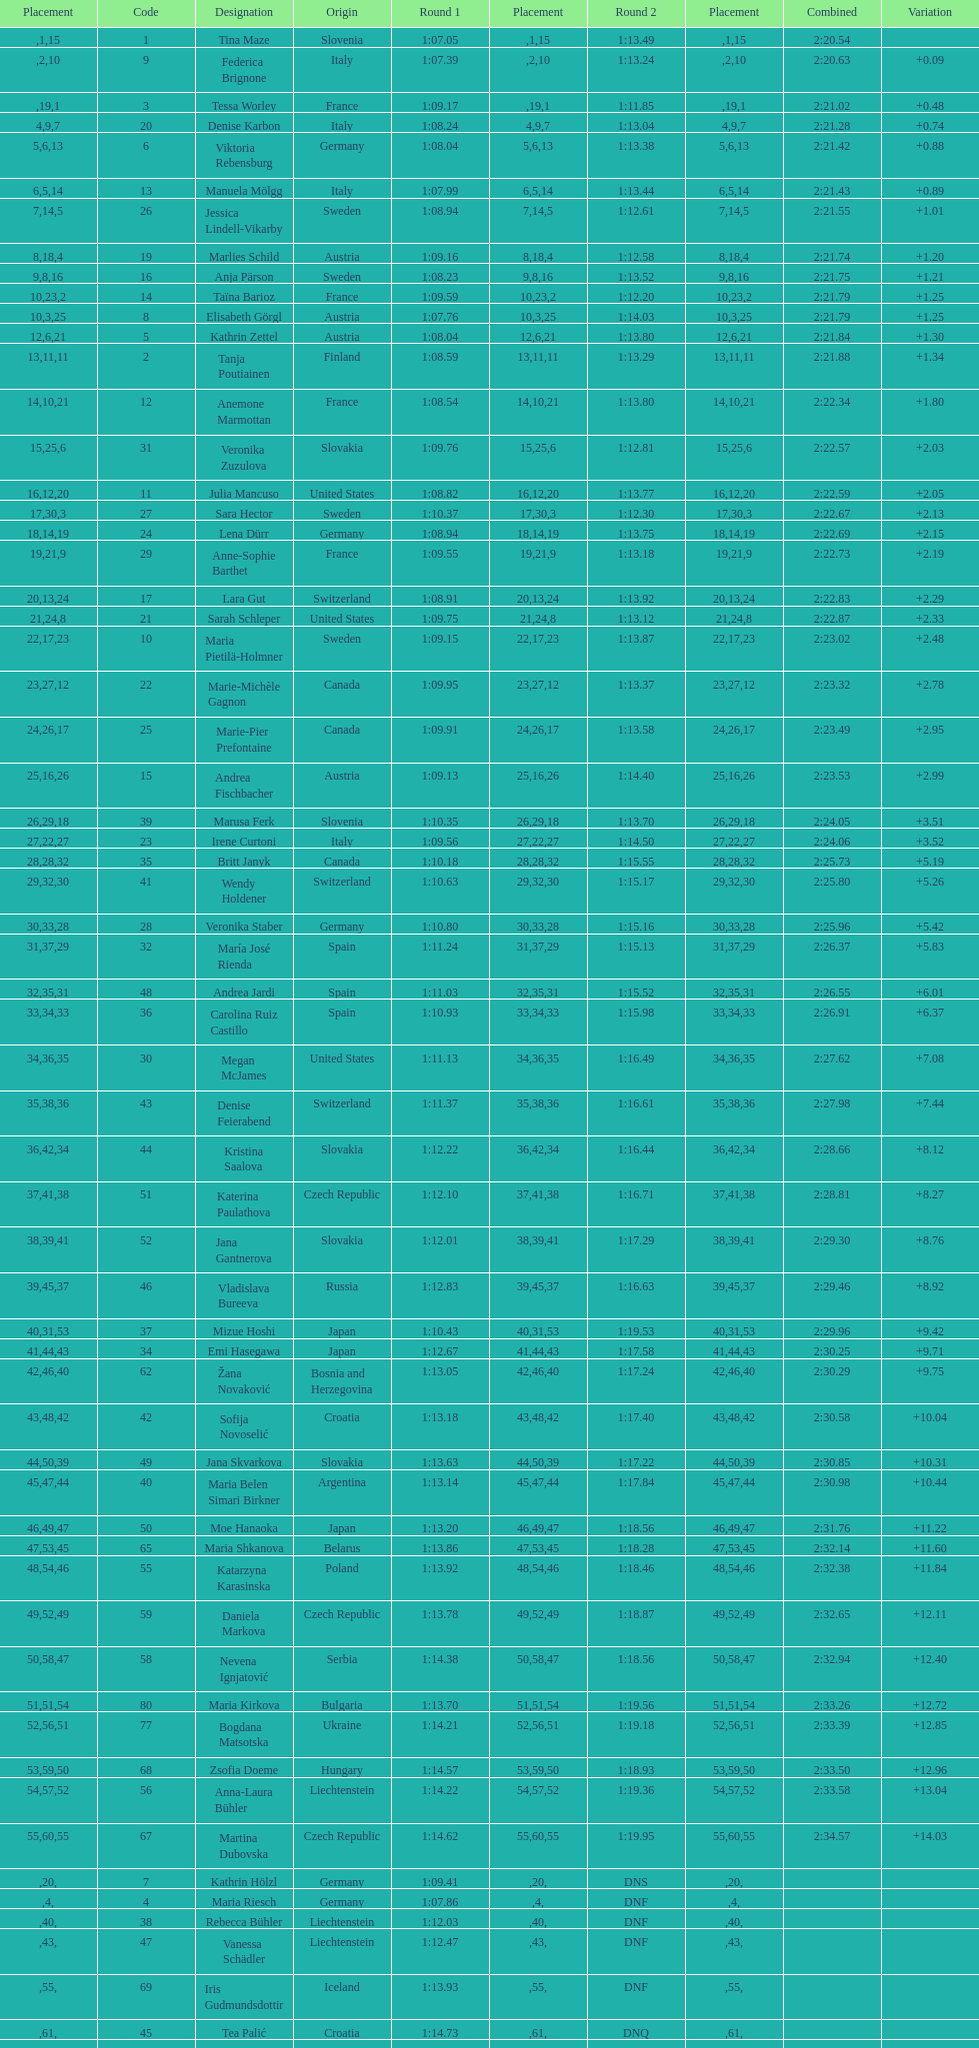What was the number of swedes in the top fifteen? 2. 